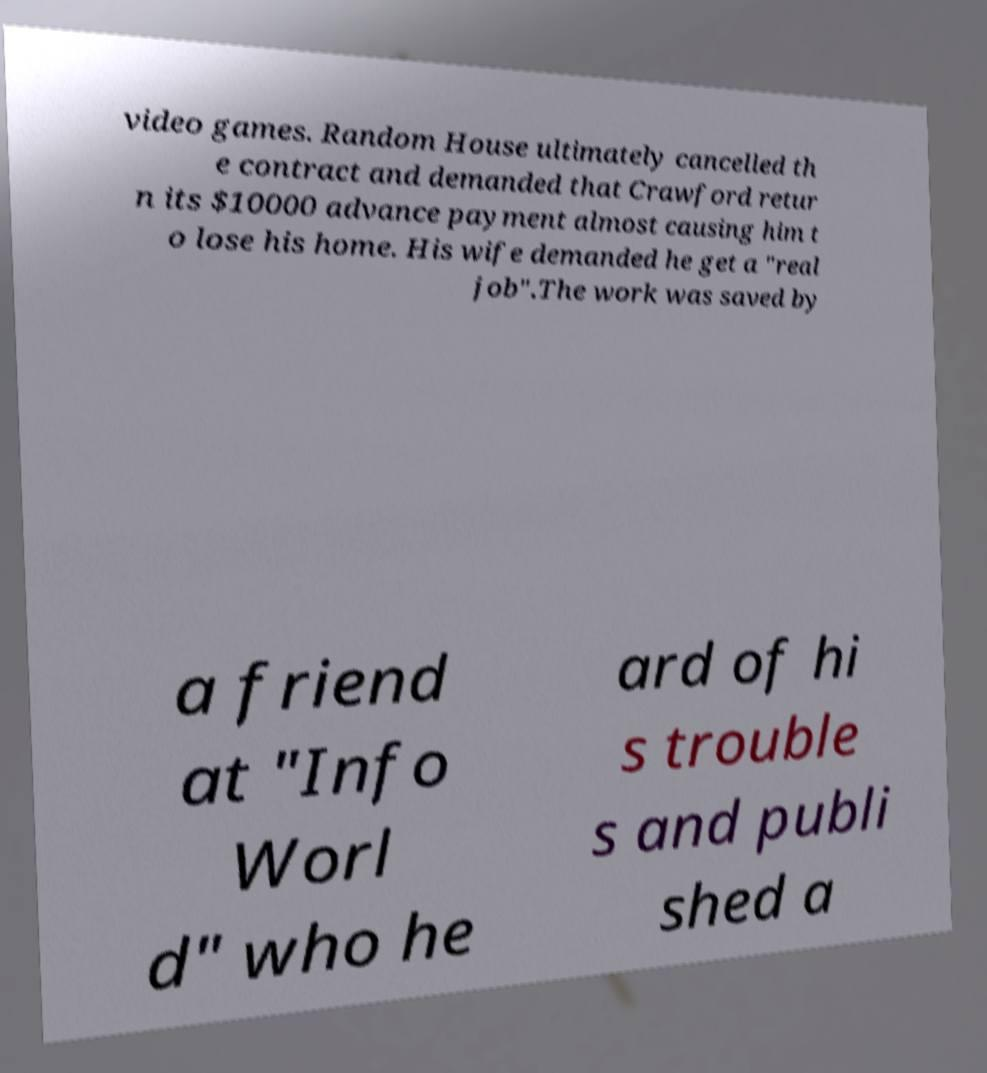Can you read and provide the text displayed in the image?This photo seems to have some interesting text. Can you extract and type it out for me? video games. Random House ultimately cancelled th e contract and demanded that Crawford retur n its $10000 advance payment almost causing him t o lose his home. His wife demanded he get a "real job".The work was saved by a friend at "Info Worl d" who he ard of hi s trouble s and publi shed a 